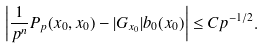<formula> <loc_0><loc_0><loc_500><loc_500>\left | \frac { 1 } { p ^ { n } } P _ { p } ( x _ { 0 } , x _ { 0 } ) - | G _ { x _ { 0 } } | b _ { 0 } ( x _ { 0 } ) \right | \leq C p ^ { - 1 / 2 } .</formula> 